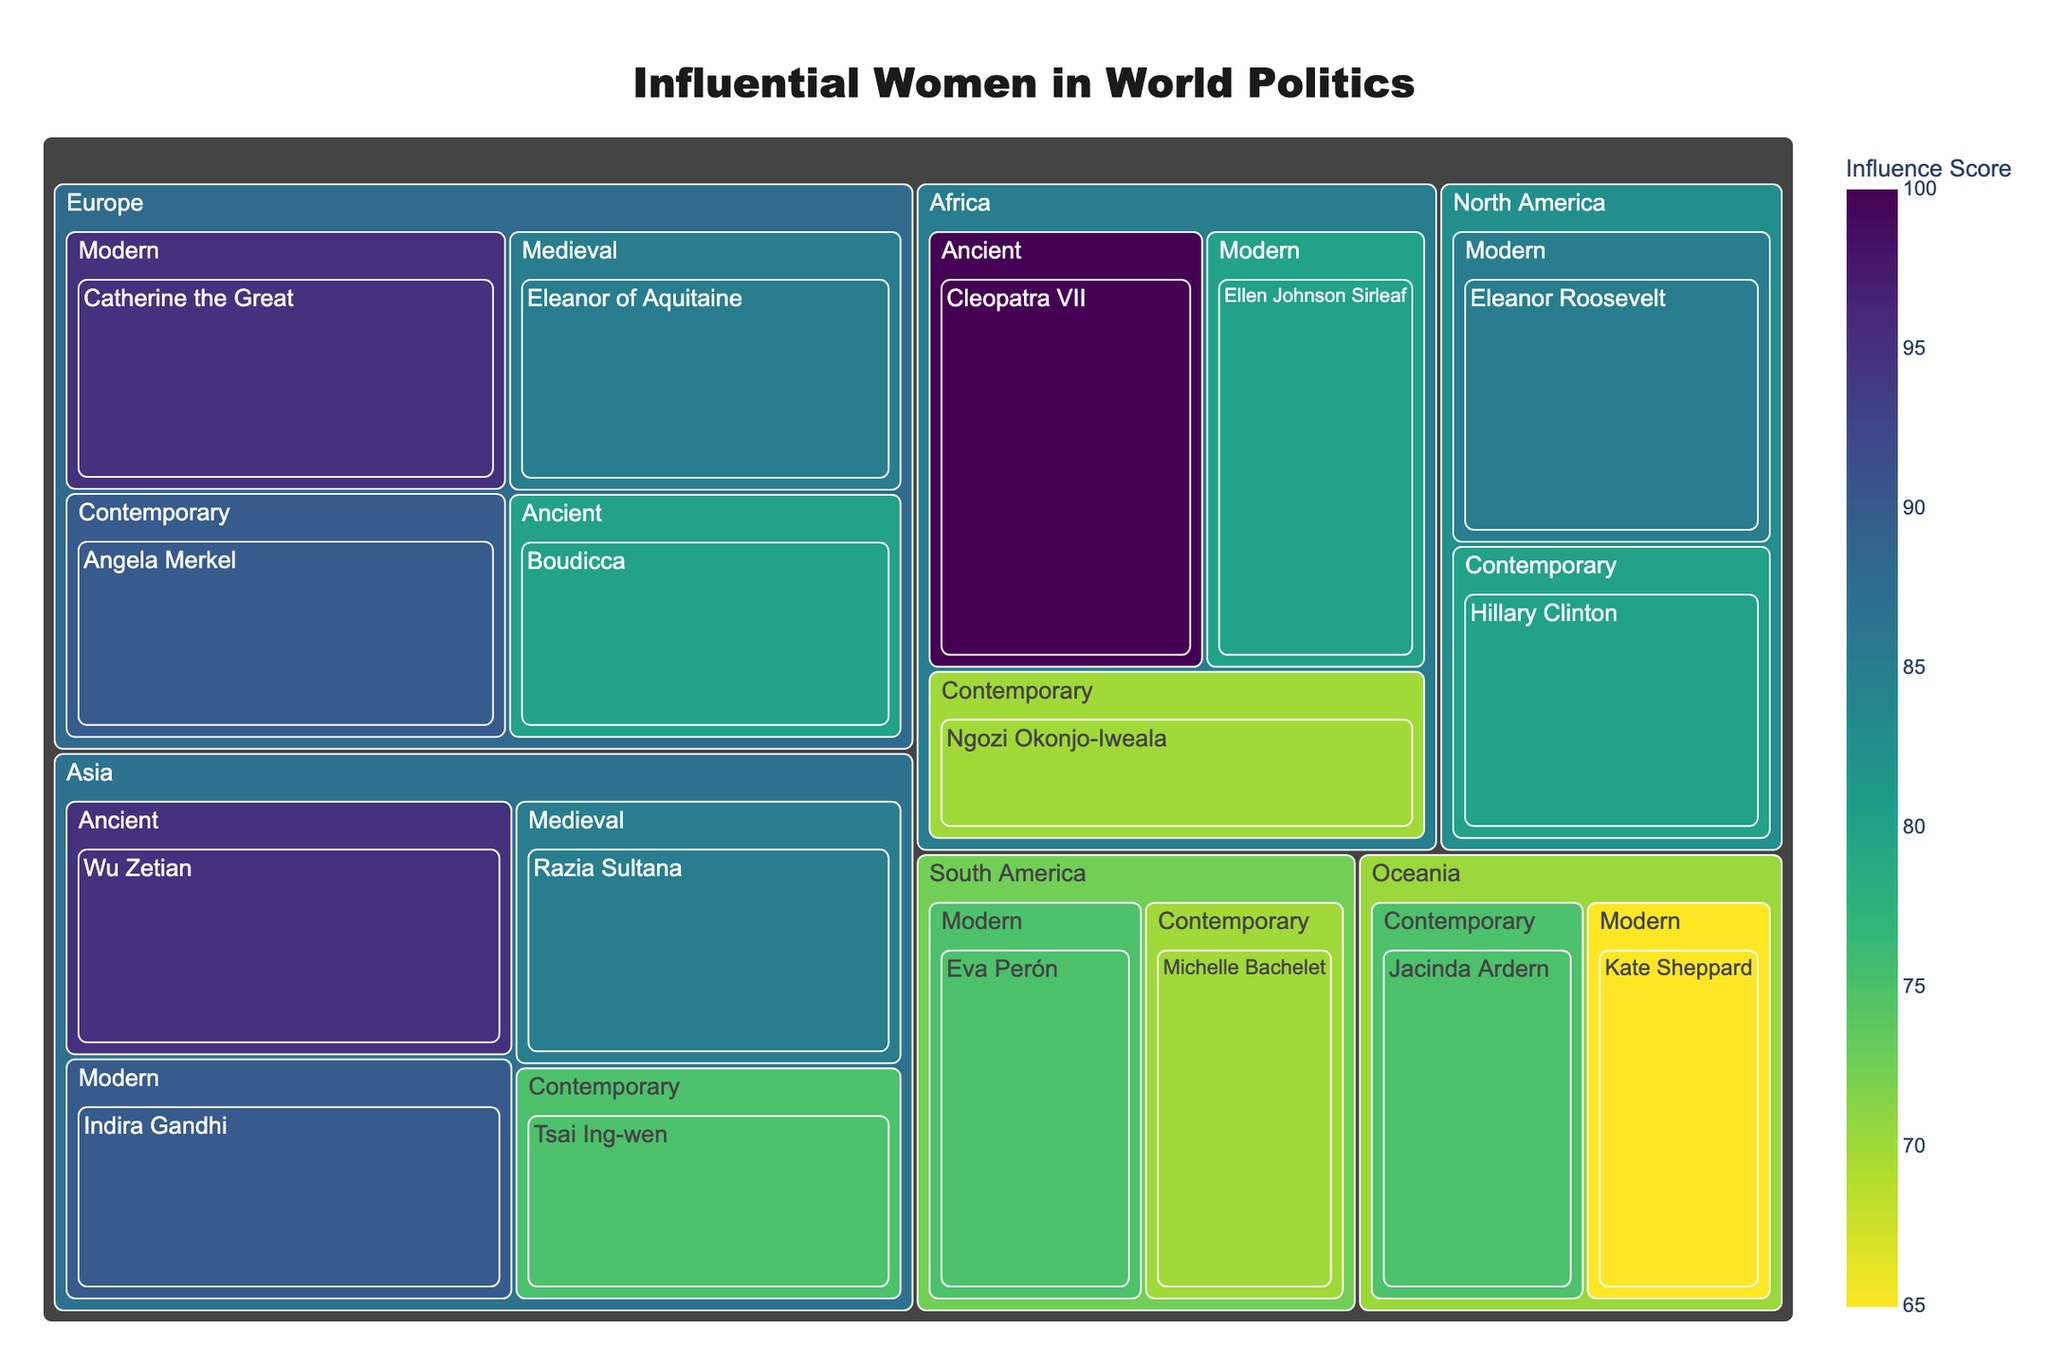Which era has the highest influence score for Africa? The figure would show the influence scores grouped by era for each continent. For Africa, Cleopatra VII in the Ancient era has the highest individual influence score at 100.
Answer: Ancient Who is the most influential woman in Europe in the contemporary era? The figure would show the names and influence scores by era. Angela Merkel, listed under the Contemporary era for Europe, has the highest influence score of 90.
Answer: Angela Merkel What's the difference in influence score between Hillary Clinton and Eleanor Roosevelt? The figure displays influence scores. Hillary Clinton has a score of 80 (Contemporary), and Eleanor Roosevelt has a score of 85 (Modern). The difference is 85 - 80.
Answer: 5 Which continent has the largest total influence for the Modern era? Add up the influence scores for the Modern era for each continent: Africa (Ellen Johnson Sirleaf: 80), Asia (Indira Gandhi: 90), Europe (Catherine the Great: 95), North America (Eleanor Roosevelt: 85), South America (Eva Perón: 75), Oceania (Kate Sheppard: 65). Europe has the highest total with 95.
Answer: Europe What is the average influence score for women listed under the Medieval era? Calculate the average of influence scores for the Medieval era: Asia (Razia Sultana: 85) and Europe (Eleanor of Aquitaine: 85). The average is (85 + 85) / 2 = 85.
Answer: 85 Which individual has the highest influence score in Asia? The figure displays influence scores for each individual in Asia. Wu Zetian in the Ancient era has the highest score of 95.
Answer: Wu Zetian Between Cleopatra VII and Catherine the Great, who has a higher influence score? Cleopatra VII has an influence score of 100, while Catherine the Great has a score of 95. Therefore, Cleopatra VII has a higher influence score.
Answer: Cleopatra VII What's the total influence score for all women listed from North America? Sum the influence scores for North America: Eleanor Roosevelt (85) and Hillary Clinton (80). The total is 85 + 80 = 165.
Answer: 165 Which continent has the widest range of influence scores among its listed individuals? Calculate the range (difference between highest and lowest influence scores) for each continent: Africa (100 - 70 = 30), Asia (95 - 75 = 20), Europe (95 - 80 = 15), North America (85 - 80 = 5), South America (75 - 70 = 5), Oceania (75 - 65 = 10). Africa has the widest range with a difference of 30.
Answer: Africa Are there more influential women listed in the Ancient era or the Contemporary era? Compare the number of women listed: 
- Ancient era: Cleopatra VII (Africa), Wu Zetian (Asia), Boudicca (Europe) - Total 3
- Contemporary era: Ngozi Okonjo-Iweala (Africa), Tsai Ing-wen (Asia), Angela Merkel (Europe), Hillary Clinton (North America), Michelle Bachelet (South America), Jacinda Ardern (Oceania) - Total 6
Thus, there are more influential women listed in the Contemporary era.
Answer: Contemporary era 